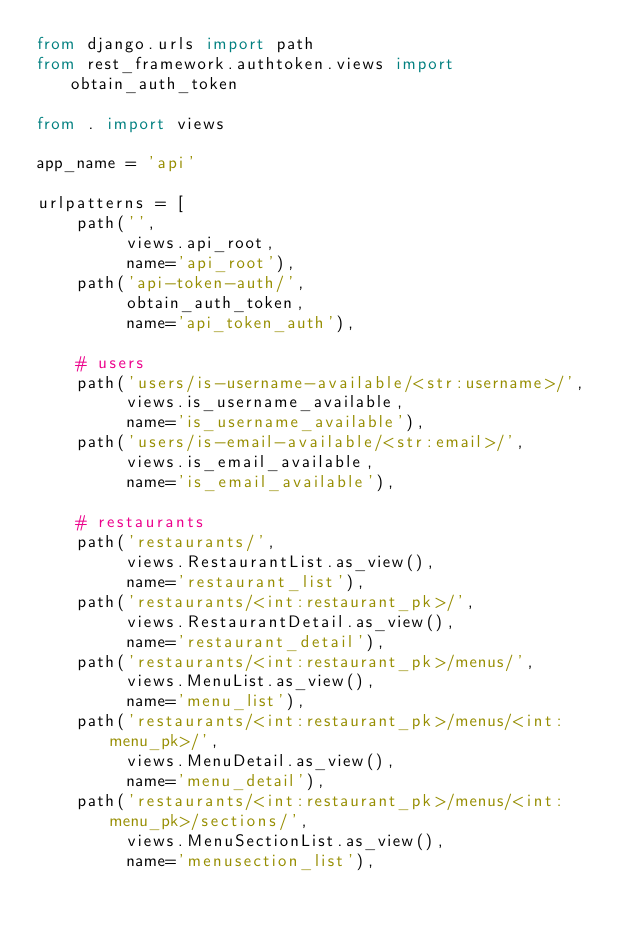<code> <loc_0><loc_0><loc_500><loc_500><_Python_>from django.urls import path
from rest_framework.authtoken.views import obtain_auth_token

from . import views

app_name = 'api'

urlpatterns = [
    path('',
         views.api_root,
         name='api_root'),
    path('api-token-auth/',
         obtain_auth_token,
         name='api_token_auth'),

    # users
    path('users/is-username-available/<str:username>/',
         views.is_username_available,
         name='is_username_available'),
    path('users/is-email-available/<str:email>/',
         views.is_email_available,
         name='is_email_available'),

    # restaurants
    path('restaurants/',
         views.RestaurantList.as_view(),
         name='restaurant_list'),
    path('restaurants/<int:restaurant_pk>/',
         views.RestaurantDetail.as_view(),
         name='restaurant_detail'),
    path('restaurants/<int:restaurant_pk>/menus/',
         views.MenuList.as_view(),
         name='menu_list'),
    path('restaurants/<int:restaurant_pk>/menus/<int:menu_pk>/',
         views.MenuDetail.as_view(),
         name='menu_detail'),
    path('restaurants/<int:restaurant_pk>/menus/<int:menu_pk>/sections/',
         views.MenuSectionList.as_view(),
         name='menusection_list'),</code> 